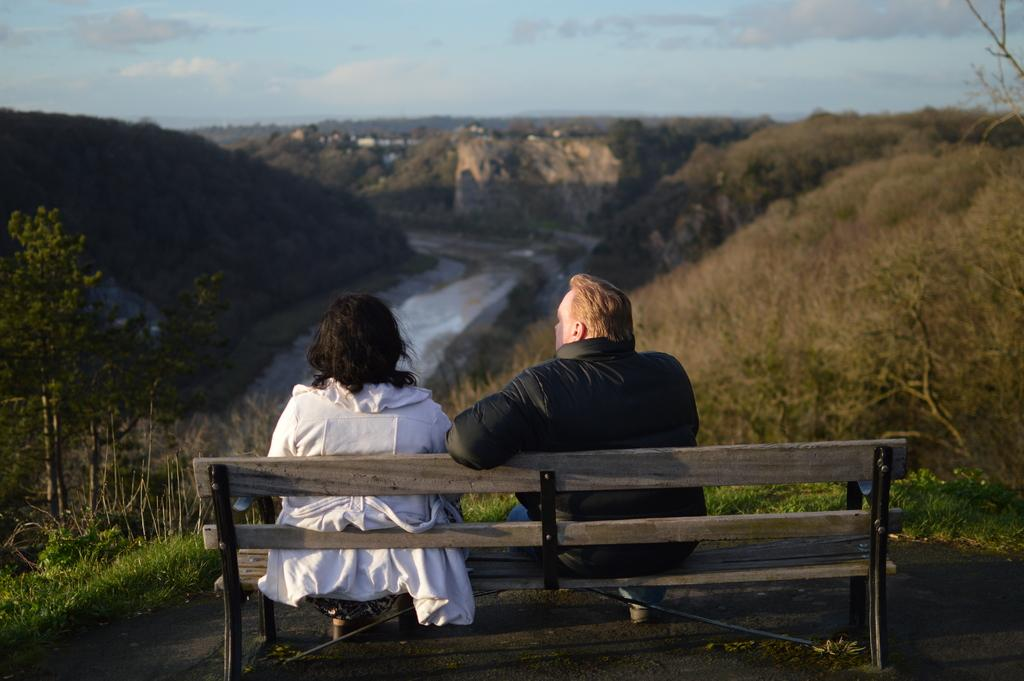Who are the two people in the image? There is a couple in the image. What are the couple doing in the image? The couple is sitting on a wooden chair. What can be seen in the background of the image? There is a sky visible in the image. What is the condition of the sky in the image? Clouds are present in the sky. What type of environment is depicted in the image? The image depicts a landscape. What type of haircut does the man in the image have? There is no information about the man's haircut in the image. What type of flesh can be seen in the image? There is no flesh visible in the image; it is a landscape scene. 